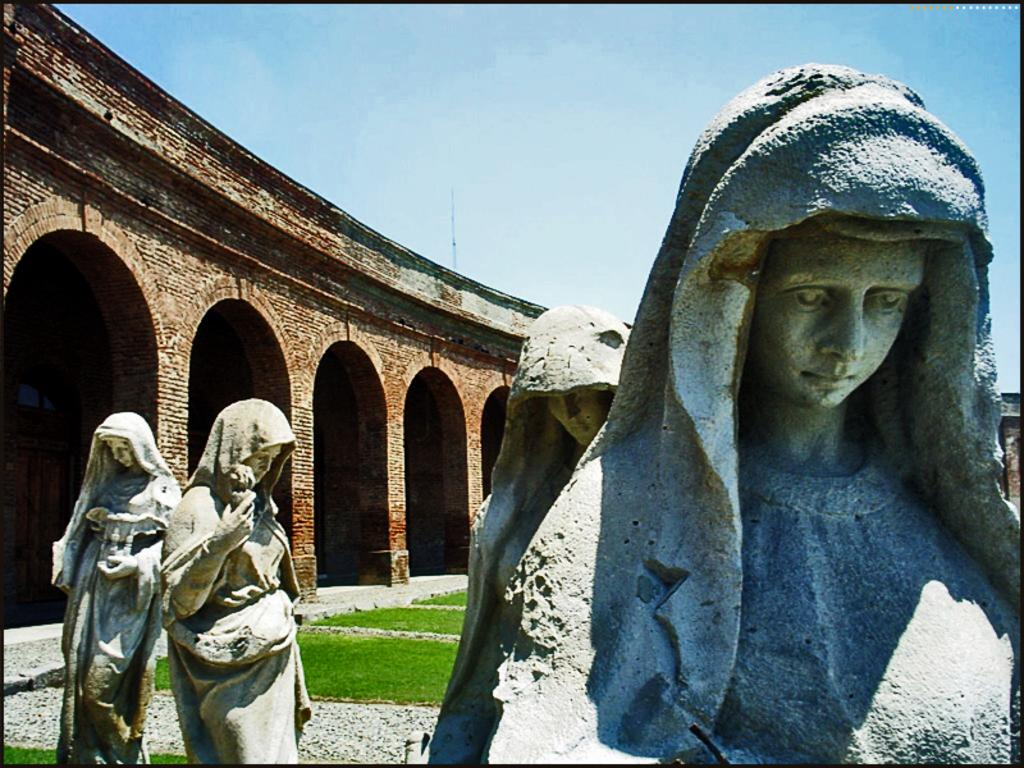What type of objects can be seen in the image? There are statues in the image. What is on the ground in the image? There is grass on the ground in the image. What can be seen in the background of the image? There is a building and the sky visible in the background of the image. What type of prose is being recited by the statues in the image? There are no statues reciting prose in the image; they are stationary objects. Is there a competition taking place between the statues in the image? There is no competition depicted in the image; the statues are simply standing in the grass. 